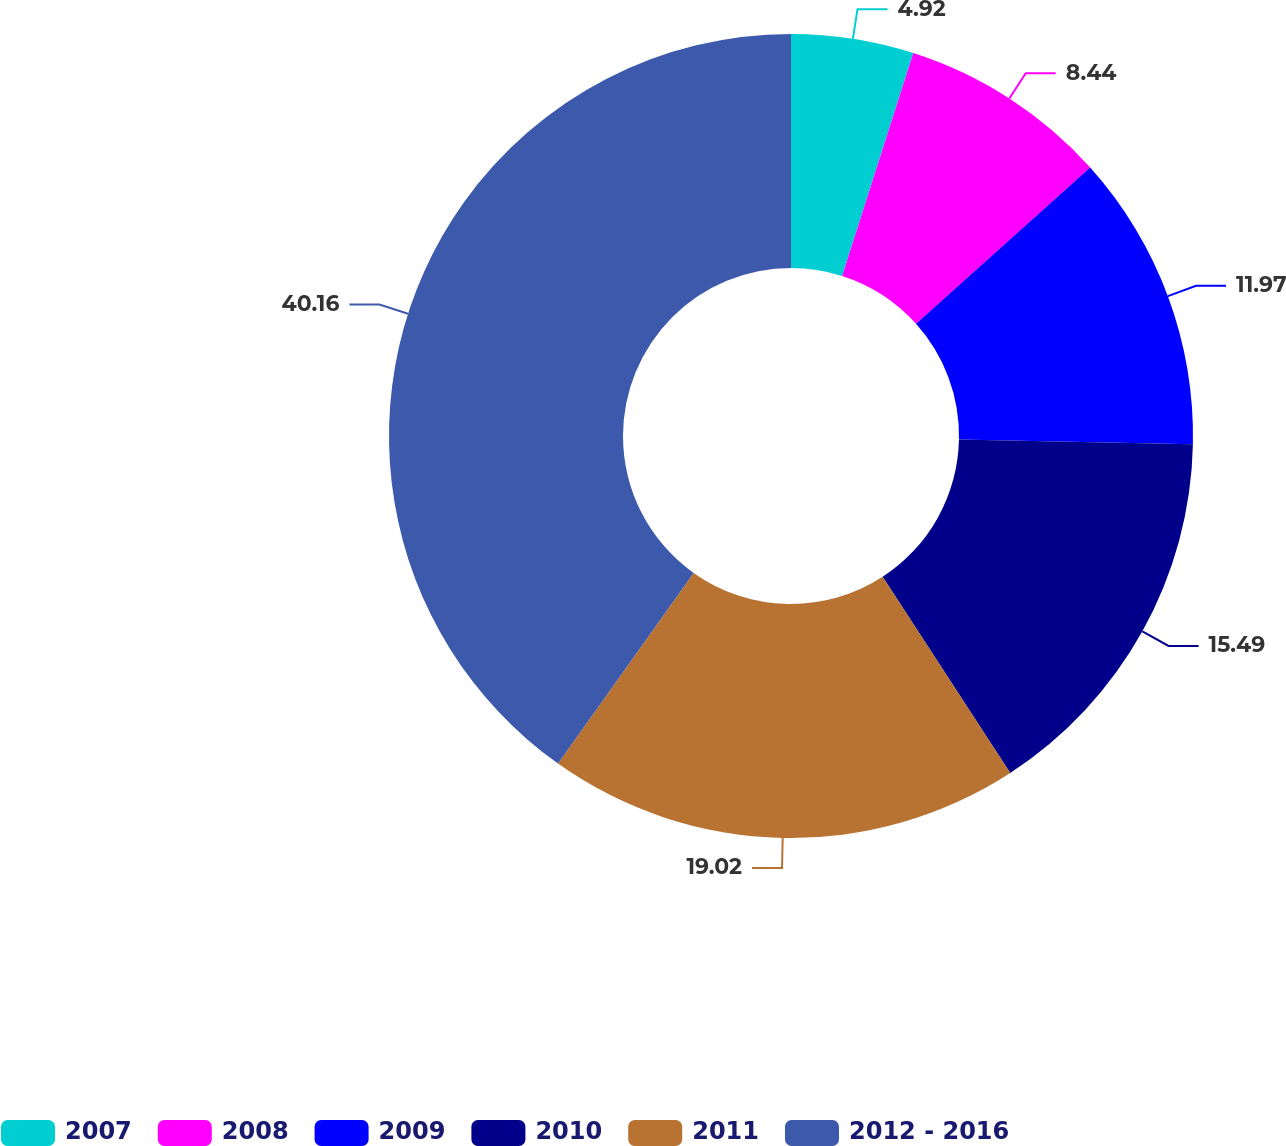Convert chart. <chart><loc_0><loc_0><loc_500><loc_500><pie_chart><fcel>2007<fcel>2008<fcel>2009<fcel>2010<fcel>2011<fcel>2012 - 2016<nl><fcel>4.92%<fcel>8.44%<fcel>11.97%<fcel>15.49%<fcel>19.02%<fcel>40.16%<nl></chart> 